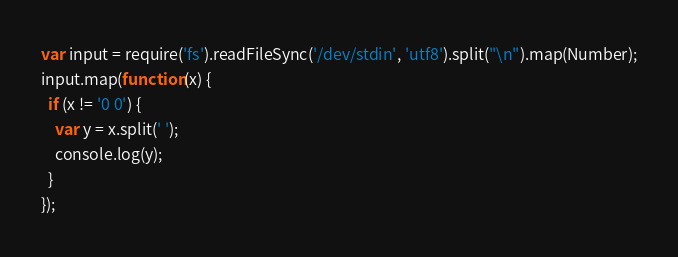Convert code to text. <code><loc_0><loc_0><loc_500><loc_500><_JavaScript_>var input = require('fs').readFileSync('/dev/stdin', 'utf8').split("\n").map(Number);
input.map(function(x) {
  if (x != '0 0') {
    var y = x.split(' ');
    console.log(y);
  }
});</code> 